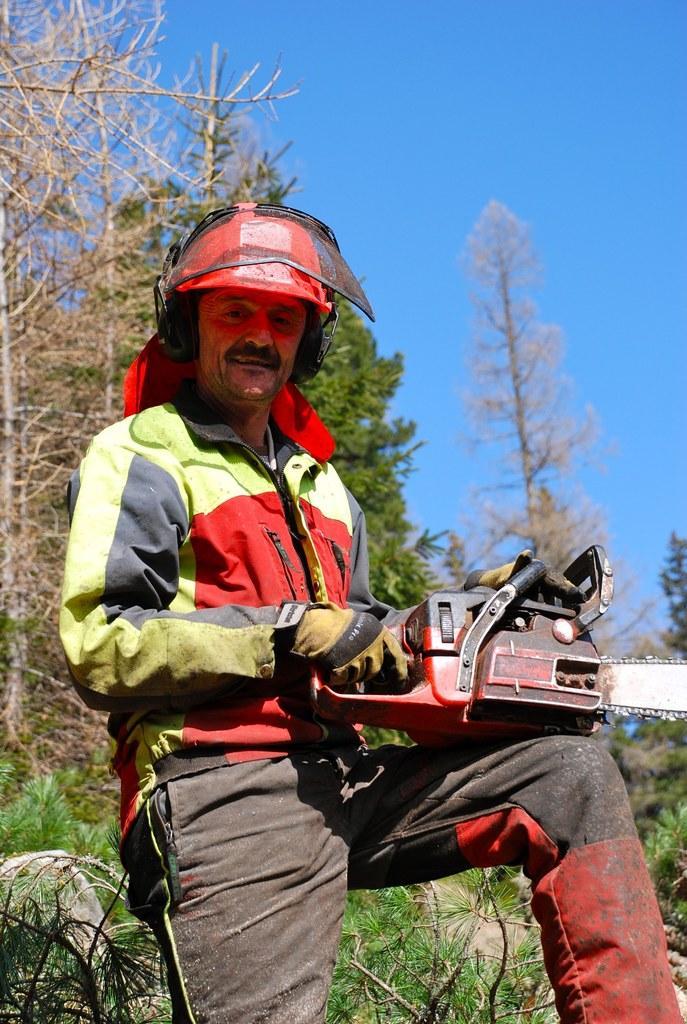Can you describe this image briefly? In this image in the foreground there is one person who is wearing a helmet, and he is holding some object. And in the background there are some trees and plants, at the top there is sky. 